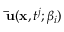<formula> <loc_0><loc_0><loc_500><loc_500>\bar { u } ( x , t ^ { j } ; \beta _ { i } )</formula> 